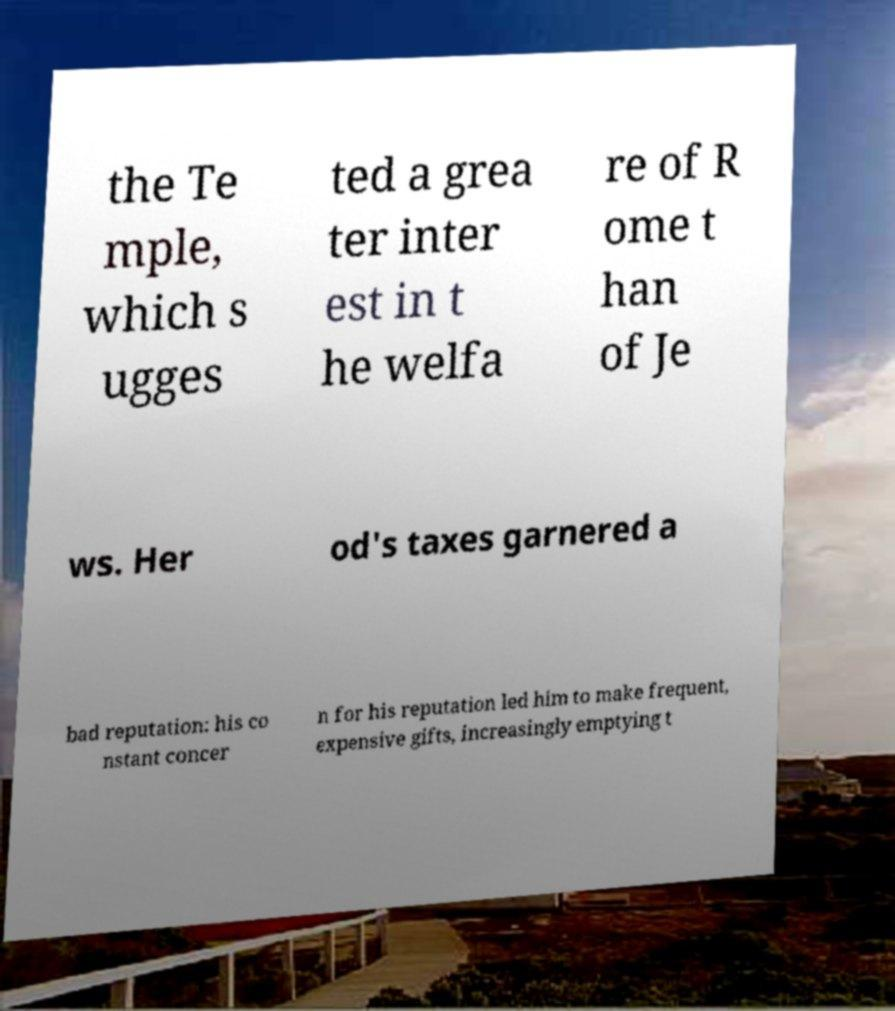For documentation purposes, I need the text within this image transcribed. Could you provide that? the Te mple, which s ugges ted a grea ter inter est in t he welfa re of R ome t han of Je ws. Her od's taxes garnered a bad reputation: his co nstant concer n for his reputation led him to make frequent, expensive gifts, increasingly emptying t 